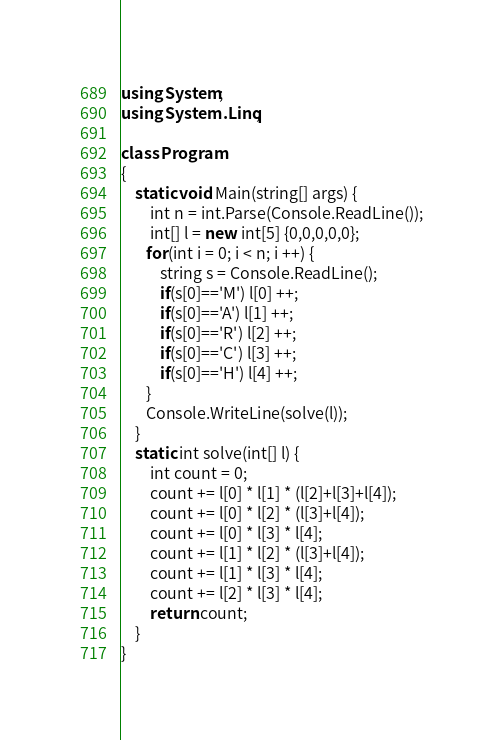<code> <loc_0><loc_0><loc_500><loc_500><_C#_>using System;
using System.Linq;

class Program
{
    static void Main(string[] args) {
        int n = int.Parse(Console.ReadLine());
        int[] l = new int[5] {0,0,0,0,0};
       for(int i = 0; i < n; i ++) {
           string s = Console.ReadLine();
           if(s[0]=='M') l[0] ++;
           if(s[0]=='A') l[1] ++;
           if(s[0]=='R') l[2] ++;
           if(s[0]=='C') l[3] ++;
           if(s[0]=='H') l[4] ++;
       }
       Console.WriteLine(solve(l));
    }
    static int solve(int[] l) {
        int count = 0;
        count += l[0] * l[1] * (l[2]+l[3]+l[4]);
        count += l[0] * l[2] * (l[3]+l[4]);
        count += l[0] * l[3] * l[4];
        count += l[1] * l[2] * (l[3]+l[4]);
        count += l[1] * l[3] * l[4];
        count += l[2] * l[3] * l[4];
        return count;
    }
}</code> 